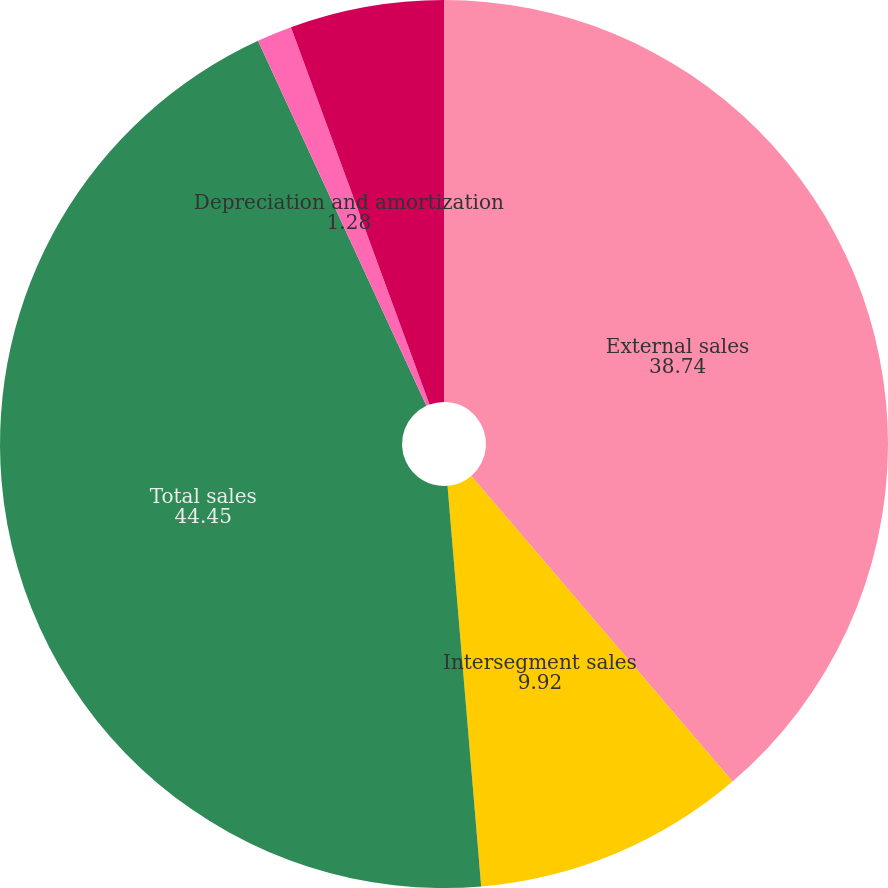<chart> <loc_0><loc_0><loc_500><loc_500><pie_chart><fcel>External sales<fcel>Intersegment sales<fcel>Total sales<fcel>Depreciation and amortization<fcel>Research development and<nl><fcel>38.74%<fcel>9.92%<fcel>44.45%<fcel>1.28%<fcel>5.6%<nl></chart> 